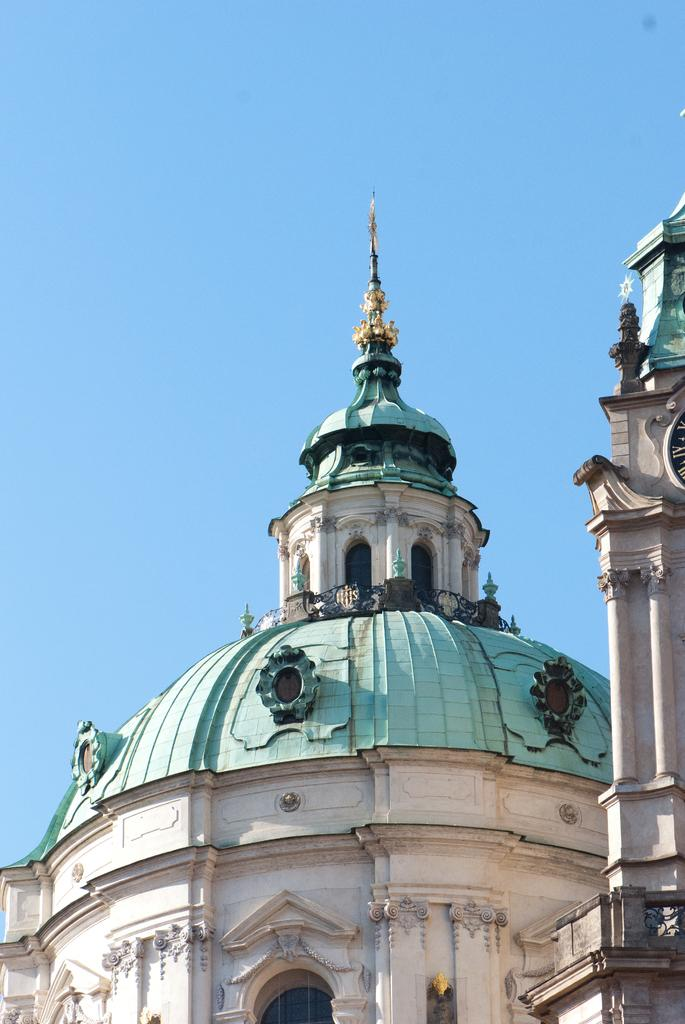What type of structures can be seen in the image? There are buildings in the image. Can you locate a specific object in the image? Yes, there is a clock on the right side of the image. Where is the lipstick placed in the image? There is no lipstick present in the image. What type of rail can be seen connecting the buildings in the image? There is no rail connecting the buildings in the image. 